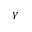Convert formula to latex. <formula><loc_0><loc_0><loc_500><loc_500>\gamma</formula> 